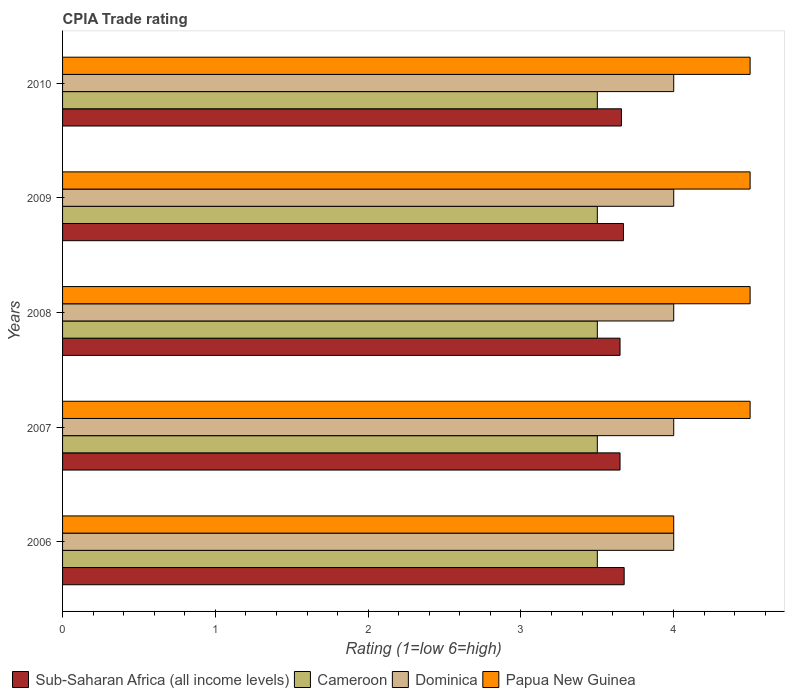Are the number of bars per tick equal to the number of legend labels?
Provide a succinct answer. Yes. How many bars are there on the 1st tick from the top?
Provide a succinct answer. 4. What is the label of the 5th group of bars from the top?
Ensure brevity in your answer.  2006. In how many cases, is the number of bars for a given year not equal to the number of legend labels?
Offer a very short reply. 0. Across all years, what is the maximum CPIA rating in Sub-Saharan Africa (all income levels)?
Offer a terse response. 3.68. Across all years, what is the minimum CPIA rating in Dominica?
Make the answer very short. 4. In which year was the CPIA rating in Dominica minimum?
Your answer should be compact. 2006. What is the total CPIA rating in Papua New Guinea in the graph?
Provide a succinct answer. 22. What is the difference between the CPIA rating in Sub-Saharan Africa (all income levels) in 2006 and that in 2007?
Offer a very short reply. 0.03. What is the difference between the CPIA rating in Cameroon in 2006 and the CPIA rating in Papua New Guinea in 2008?
Your response must be concise. -1. In the year 2007, what is the difference between the CPIA rating in Cameroon and CPIA rating in Sub-Saharan Africa (all income levels)?
Keep it short and to the point. -0.15. What is the ratio of the CPIA rating in Papua New Guinea in 2006 to that in 2009?
Make the answer very short. 0.89. Is the CPIA rating in Dominica in 2007 less than that in 2010?
Offer a very short reply. No. Is the difference between the CPIA rating in Cameroon in 2006 and 2007 greater than the difference between the CPIA rating in Sub-Saharan Africa (all income levels) in 2006 and 2007?
Make the answer very short. No. What is the difference between the highest and the second highest CPIA rating in Dominica?
Make the answer very short. 0. What does the 4th bar from the top in 2007 represents?
Make the answer very short. Sub-Saharan Africa (all income levels). What does the 1st bar from the bottom in 2006 represents?
Offer a very short reply. Sub-Saharan Africa (all income levels). How many bars are there?
Make the answer very short. 20. Are all the bars in the graph horizontal?
Provide a succinct answer. Yes. How many years are there in the graph?
Provide a succinct answer. 5. What is the difference between two consecutive major ticks on the X-axis?
Provide a succinct answer. 1. Does the graph contain grids?
Offer a very short reply. No. How are the legend labels stacked?
Offer a very short reply. Horizontal. What is the title of the graph?
Offer a very short reply. CPIA Trade rating. Does "Papua New Guinea" appear as one of the legend labels in the graph?
Offer a very short reply. Yes. What is the label or title of the Y-axis?
Your answer should be very brief. Years. What is the Rating (1=low 6=high) in Sub-Saharan Africa (all income levels) in 2006?
Give a very brief answer. 3.68. What is the Rating (1=low 6=high) in Sub-Saharan Africa (all income levels) in 2007?
Your response must be concise. 3.65. What is the Rating (1=low 6=high) in Cameroon in 2007?
Make the answer very short. 3.5. What is the Rating (1=low 6=high) in Dominica in 2007?
Make the answer very short. 4. What is the Rating (1=low 6=high) in Sub-Saharan Africa (all income levels) in 2008?
Provide a short and direct response. 3.65. What is the Rating (1=low 6=high) of Cameroon in 2008?
Your answer should be compact. 3.5. What is the Rating (1=low 6=high) of Sub-Saharan Africa (all income levels) in 2009?
Your answer should be very brief. 3.67. What is the Rating (1=low 6=high) of Dominica in 2009?
Provide a short and direct response. 4. What is the Rating (1=low 6=high) of Papua New Guinea in 2009?
Offer a very short reply. 4.5. What is the Rating (1=low 6=high) of Sub-Saharan Africa (all income levels) in 2010?
Offer a very short reply. 3.66. Across all years, what is the maximum Rating (1=low 6=high) in Sub-Saharan Africa (all income levels)?
Offer a very short reply. 3.68. Across all years, what is the maximum Rating (1=low 6=high) of Papua New Guinea?
Keep it short and to the point. 4.5. Across all years, what is the minimum Rating (1=low 6=high) in Sub-Saharan Africa (all income levels)?
Provide a succinct answer. 3.65. What is the total Rating (1=low 6=high) in Sub-Saharan Africa (all income levels) in the graph?
Give a very brief answer. 18.3. What is the total Rating (1=low 6=high) in Cameroon in the graph?
Your response must be concise. 17.5. What is the difference between the Rating (1=low 6=high) of Sub-Saharan Africa (all income levels) in 2006 and that in 2007?
Your response must be concise. 0.03. What is the difference between the Rating (1=low 6=high) of Dominica in 2006 and that in 2007?
Your response must be concise. 0. What is the difference between the Rating (1=low 6=high) in Sub-Saharan Africa (all income levels) in 2006 and that in 2008?
Make the answer very short. 0.03. What is the difference between the Rating (1=low 6=high) of Cameroon in 2006 and that in 2008?
Keep it short and to the point. 0. What is the difference between the Rating (1=low 6=high) of Dominica in 2006 and that in 2008?
Your answer should be compact. 0. What is the difference between the Rating (1=low 6=high) in Sub-Saharan Africa (all income levels) in 2006 and that in 2009?
Ensure brevity in your answer.  0. What is the difference between the Rating (1=low 6=high) in Cameroon in 2006 and that in 2009?
Make the answer very short. 0. What is the difference between the Rating (1=low 6=high) of Sub-Saharan Africa (all income levels) in 2006 and that in 2010?
Offer a terse response. 0.02. What is the difference between the Rating (1=low 6=high) in Papua New Guinea in 2006 and that in 2010?
Your response must be concise. -0.5. What is the difference between the Rating (1=low 6=high) of Papua New Guinea in 2007 and that in 2008?
Give a very brief answer. 0. What is the difference between the Rating (1=low 6=high) of Sub-Saharan Africa (all income levels) in 2007 and that in 2009?
Provide a short and direct response. -0.02. What is the difference between the Rating (1=low 6=high) of Dominica in 2007 and that in 2009?
Your response must be concise. 0. What is the difference between the Rating (1=low 6=high) in Papua New Guinea in 2007 and that in 2009?
Provide a short and direct response. 0. What is the difference between the Rating (1=low 6=high) in Sub-Saharan Africa (all income levels) in 2007 and that in 2010?
Make the answer very short. -0.01. What is the difference between the Rating (1=low 6=high) of Dominica in 2007 and that in 2010?
Provide a short and direct response. 0. What is the difference between the Rating (1=low 6=high) in Sub-Saharan Africa (all income levels) in 2008 and that in 2009?
Your response must be concise. -0.02. What is the difference between the Rating (1=low 6=high) of Sub-Saharan Africa (all income levels) in 2008 and that in 2010?
Offer a terse response. -0.01. What is the difference between the Rating (1=low 6=high) of Cameroon in 2008 and that in 2010?
Provide a short and direct response. 0. What is the difference between the Rating (1=low 6=high) in Sub-Saharan Africa (all income levels) in 2009 and that in 2010?
Your answer should be very brief. 0.01. What is the difference between the Rating (1=low 6=high) of Cameroon in 2009 and that in 2010?
Your answer should be compact. 0. What is the difference between the Rating (1=low 6=high) of Papua New Guinea in 2009 and that in 2010?
Provide a succinct answer. 0. What is the difference between the Rating (1=low 6=high) in Sub-Saharan Africa (all income levels) in 2006 and the Rating (1=low 6=high) in Cameroon in 2007?
Make the answer very short. 0.18. What is the difference between the Rating (1=low 6=high) in Sub-Saharan Africa (all income levels) in 2006 and the Rating (1=low 6=high) in Dominica in 2007?
Your answer should be very brief. -0.32. What is the difference between the Rating (1=low 6=high) in Sub-Saharan Africa (all income levels) in 2006 and the Rating (1=low 6=high) in Papua New Guinea in 2007?
Offer a very short reply. -0.82. What is the difference between the Rating (1=low 6=high) of Cameroon in 2006 and the Rating (1=low 6=high) of Dominica in 2007?
Provide a succinct answer. -0.5. What is the difference between the Rating (1=low 6=high) in Cameroon in 2006 and the Rating (1=low 6=high) in Papua New Guinea in 2007?
Make the answer very short. -1. What is the difference between the Rating (1=low 6=high) in Dominica in 2006 and the Rating (1=low 6=high) in Papua New Guinea in 2007?
Your answer should be compact. -0.5. What is the difference between the Rating (1=low 6=high) in Sub-Saharan Africa (all income levels) in 2006 and the Rating (1=low 6=high) in Cameroon in 2008?
Your answer should be compact. 0.18. What is the difference between the Rating (1=low 6=high) in Sub-Saharan Africa (all income levels) in 2006 and the Rating (1=low 6=high) in Dominica in 2008?
Offer a terse response. -0.32. What is the difference between the Rating (1=low 6=high) of Sub-Saharan Africa (all income levels) in 2006 and the Rating (1=low 6=high) of Papua New Guinea in 2008?
Make the answer very short. -0.82. What is the difference between the Rating (1=low 6=high) of Cameroon in 2006 and the Rating (1=low 6=high) of Dominica in 2008?
Offer a very short reply. -0.5. What is the difference between the Rating (1=low 6=high) of Dominica in 2006 and the Rating (1=low 6=high) of Papua New Guinea in 2008?
Make the answer very short. -0.5. What is the difference between the Rating (1=low 6=high) of Sub-Saharan Africa (all income levels) in 2006 and the Rating (1=low 6=high) of Cameroon in 2009?
Give a very brief answer. 0.18. What is the difference between the Rating (1=low 6=high) in Sub-Saharan Africa (all income levels) in 2006 and the Rating (1=low 6=high) in Dominica in 2009?
Provide a succinct answer. -0.32. What is the difference between the Rating (1=low 6=high) of Sub-Saharan Africa (all income levels) in 2006 and the Rating (1=low 6=high) of Papua New Guinea in 2009?
Ensure brevity in your answer.  -0.82. What is the difference between the Rating (1=low 6=high) in Sub-Saharan Africa (all income levels) in 2006 and the Rating (1=low 6=high) in Cameroon in 2010?
Keep it short and to the point. 0.18. What is the difference between the Rating (1=low 6=high) in Sub-Saharan Africa (all income levels) in 2006 and the Rating (1=low 6=high) in Dominica in 2010?
Provide a short and direct response. -0.32. What is the difference between the Rating (1=low 6=high) of Sub-Saharan Africa (all income levels) in 2006 and the Rating (1=low 6=high) of Papua New Guinea in 2010?
Keep it short and to the point. -0.82. What is the difference between the Rating (1=low 6=high) of Cameroon in 2006 and the Rating (1=low 6=high) of Papua New Guinea in 2010?
Keep it short and to the point. -1. What is the difference between the Rating (1=low 6=high) in Sub-Saharan Africa (all income levels) in 2007 and the Rating (1=low 6=high) in Cameroon in 2008?
Make the answer very short. 0.15. What is the difference between the Rating (1=low 6=high) of Sub-Saharan Africa (all income levels) in 2007 and the Rating (1=low 6=high) of Dominica in 2008?
Give a very brief answer. -0.35. What is the difference between the Rating (1=low 6=high) in Sub-Saharan Africa (all income levels) in 2007 and the Rating (1=low 6=high) in Papua New Guinea in 2008?
Your answer should be compact. -0.85. What is the difference between the Rating (1=low 6=high) of Dominica in 2007 and the Rating (1=low 6=high) of Papua New Guinea in 2008?
Ensure brevity in your answer.  -0.5. What is the difference between the Rating (1=low 6=high) in Sub-Saharan Africa (all income levels) in 2007 and the Rating (1=low 6=high) in Cameroon in 2009?
Offer a very short reply. 0.15. What is the difference between the Rating (1=low 6=high) in Sub-Saharan Africa (all income levels) in 2007 and the Rating (1=low 6=high) in Dominica in 2009?
Offer a very short reply. -0.35. What is the difference between the Rating (1=low 6=high) in Sub-Saharan Africa (all income levels) in 2007 and the Rating (1=low 6=high) in Papua New Guinea in 2009?
Your answer should be very brief. -0.85. What is the difference between the Rating (1=low 6=high) of Cameroon in 2007 and the Rating (1=low 6=high) of Dominica in 2009?
Your answer should be very brief. -0.5. What is the difference between the Rating (1=low 6=high) of Sub-Saharan Africa (all income levels) in 2007 and the Rating (1=low 6=high) of Cameroon in 2010?
Offer a terse response. 0.15. What is the difference between the Rating (1=low 6=high) of Sub-Saharan Africa (all income levels) in 2007 and the Rating (1=low 6=high) of Dominica in 2010?
Your answer should be very brief. -0.35. What is the difference between the Rating (1=low 6=high) in Sub-Saharan Africa (all income levels) in 2007 and the Rating (1=low 6=high) in Papua New Guinea in 2010?
Offer a very short reply. -0.85. What is the difference between the Rating (1=low 6=high) in Cameroon in 2007 and the Rating (1=low 6=high) in Dominica in 2010?
Your answer should be very brief. -0.5. What is the difference between the Rating (1=low 6=high) of Cameroon in 2007 and the Rating (1=low 6=high) of Papua New Guinea in 2010?
Offer a very short reply. -1. What is the difference between the Rating (1=low 6=high) of Sub-Saharan Africa (all income levels) in 2008 and the Rating (1=low 6=high) of Cameroon in 2009?
Ensure brevity in your answer.  0.15. What is the difference between the Rating (1=low 6=high) of Sub-Saharan Africa (all income levels) in 2008 and the Rating (1=low 6=high) of Dominica in 2009?
Provide a short and direct response. -0.35. What is the difference between the Rating (1=low 6=high) in Sub-Saharan Africa (all income levels) in 2008 and the Rating (1=low 6=high) in Papua New Guinea in 2009?
Your answer should be compact. -0.85. What is the difference between the Rating (1=low 6=high) of Cameroon in 2008 and the Rating (1=low 6=high) of Dominica in 2009?
Offer a terse response. -0.5. What is the difference between the Rating (1=low 6=high) in Sub-Saharan Africa (all income levels) in 2008 and the Rating (1=low 6=high) in Cameroon in 2010?
Offer a terse response. 0.15. What is the difference between the Rating (1=low 6=high) of Sub-Saharan Africa (all income levels) in 2008 and the Rating (1=low 6=high) of Dominica in 2010?
Offer a very short reply. -0.35. What is the difference between the Rating (1=low 6=high) of Sub-Saharan Africa (all income levels) in 2008 and the Rating (1=low 6=high) of Papua New Guinea in 2010?
Offer a very short reply. -0.85. What is the difference between the Rating (1=low 6=high) in Cameroon in 2008 and the Rating (1=low 6=high) in Papua New Guinea in 2010?
Provide a succinct answer. -1. What is the difference between the Rating (1=low 6=high) in Sub-Saharan Africa (all income levels) in 2009 and the Rating (1=low 6=high) in Cameroon in 2010?
Ensure brevity in your answer.  0.17. What is the difference between the Rating (1=low 6=high) of Sub-Saharan Africa (all income levels) in 2009 and the Rating (1=low 6=high) of Dominica in 2010?
Provide a short and direct response. -0.33. What is the difference between the Rating (1=low 6=high) in Sub-Saharan Africa (all income levels) in 2009 and the Rating (1=low 6=high) in Papua New Guinea in 2010?
Ensure brevity in your answer.  -0.83. What is the difference between the Rating (1=low 6=high) in Cameroon in 2009 and the Rating (1=low 6=high) in Papua New Guinea in 2010?
Offer a terse response. -1. What is the average Rating (1=low 6=high) in Sub-Saharan Africa (all income levels) per year?
Give a very brief answer. 3.66. What is the average Rating (1=low 6=high) in Dominica per year?
Give a very brief answer. 4. In the year 2006, what is the difference between the Rating (1=low 6=high) of Sub-Saharan Africa (all income levels) and Rating (1=low 6=high) of Cameroon?
Provide a succinct answer. 0.18. In the year 2006, what is the difference between the Rating (1=low 6=high) in Sub-Saharan Africa (all income levels) and Rating (1=low 6=high) in Dominica?
Keep it short and to the point. -0.32. In the year 2006, what is the difference between the Rating (1=low 6=high) of Sub-Saharan Africa (all income levels) and Rating (1=low 6=high) of Papua New Guinea?
Ensure brevity in your answer.  -0.32. In the year 2007, what is the difference between the Rating (1=low 6=high) of Sub-Saharan Africa (all income levels) and Rating (1=low 6=high) of Cameroon?
Offer a very short reply. 0.15. In the year 2007, what is the difference between the Rating (1=low 6=high) in Sub-Saharan Africa (all income levels) and Rating (1=low 6=high) in Dominica?
Your response must be concise. -0.35. In the year 2007, what is the difference between the Rating (1=low 6=high) of Sub-Saharan Africa (all income levels) and Rating (1=low 6=high) of Papua New Guinea?
Make the answer very short. -0.85. In the year 2007, what is the difference between the Rating (1=low 6=high) in Cameroon and Rating (1=low 6=high) in Papua New Guinea?
Make the answer very short. -1. In the year 2007, what is the difference between the Rating (1=low 6=high) of Dominica and Rating (1=low 6=high) of Papua New Guinea?
Your response must be concise. -0.5. In the year 2008, what is the difference between the Rating (1=low 6=high) of Sub-Saharan Africa (all income levels) and Rating (1=low 6=high) of Cameroon?
Make the answer very short. 0.15. In the year 2008, what is the difference between the Rating (1=low 6=high) in Sub-Saharan Africa (all income levels) and Rating (1=low 6=high) in Dominica?
Offer a very short reply. -0.35. In the year 2008, what is the difference between the Rating (1=low 6=high) of Sub-Saharan Africa (all income levels) and Rating (1=low 6=high) of Papua New Guinea?
Your response must be concise. -0.85. In the year 2008, what is the difference between the Rating (1=low 6=high) in Cameroon and Rating (1=low 6=high) in Dominica?
Provide a succinct answer. -0.5. In the year 2008, what is the difference between the Rating (1=low 6=high) in Cameroon and Rating (1=low 6=high) in Papua New Guinea?
Provide a short and direct response. -1. In the year 2008, what is the difference between the Rating (1=low 6=high) in Dominica and Rating (1=low 6=high) in Papua New Guinea?
Provide a short and direct response. -0.5. In the year 2009, what is the difference between the Rating (1=low 6=high) of Sub-Saharan Africa (all income levels) and Rating (1=low 6=high) of Cameroon?
Ensure brevity in your answer.  0.17. In the year 2009, what is the difference between the Rating (1=low 6=high) in Sub-Saharan Africa (all income levels) and Rating (1=low 6=high) in Dominica?
Ensure brevity in your answer.  -0.33. In the year 2009, what is the difference between the Rating (1=low 6=high) of Sub-Saharan Africa (all income levels) and Rating (1=low 6=high) of Papua New Guinea?
Make the answer very short. -0.83. In the year 2009, what is the difference between the Rating (1=low 6=high) in Cameroon and Rating (1=low 6=high) in Dominica?
Your answer should be very brief. -0.5. In the year 2009, what is the difference between the Rating (1=low 6=high) of Cameroon and Rating (1=low 6=high) of Papua New Guinea?
Provide a succinct answer. -1. In the year 2010, what is the difference between the Rating (1=low 6=high) in Sub-Saharan Africa (all income levels) and Rating (1=low 6=high) in Cameroon?
Provide a short and direct response. 0.16. In the year 2010, what is the difference between the Rating (1=low 6=high) of Sub-Saharan Africa (all income levels) and Rating (1=low 6=high) of Dominica?
Provide a succinct answer. -0.34. In the year 2010, what is the difference between the Rating (1=low 6=high) of Sub-Saharan Africa (all income levels) and Rating (1=low 6=high) of Papua New Guinea?
Keep it short and to the point. -0.84. In the year 2010, what is the difference between the Rating (1=low 6=high) in Cameroon and Rating (1=low 6=high) in Dominica?
Ensure brevity in your answer.  -0.5. In the year 2010, what is the difference between the Rating (1=low 6=high) of Dominica and Rating (1=low 6=high) of Papua New Guinea?
Ensure brevity in your answer.  -0.5. What is the ratio of the Rating (1=low 6=high) in Sub-Saharan Africa (all income levels) in 2006 to that in 2007?
Offer a terse response. 1.01. What is the ratio of the Rating (1=low 6=high) in Cameroon in 2006 to that in 2007?
Provide a succinct answer. 1. What is the ratio of the Rating (1=low 6=high) in Dominica in 2006 to that in 2007?
Make the answer very short. 1. What is the ratio of the Rating (1=low 6=high) of Sub-Saharan Africa (all income levels) in 2006 to that in 2008?
Keep it short and to the point. 1.01. What is the ratio of the Rating (1=low 6=high) of Cameroon in 2006 to that in 2009?
Give a very brief answer. 1. What is the ratio of the Rating (1=low 6=high) in Sub-Saharan Africa (all income levels) in 2006 to that in 2010?
Your answer should be very brief. 1. What is the ratio of the Rating (1=low 6=high) of Dominica in 2006 to that in 2010?
Offer a terse response. 1. What is the ratio of the Rating (1=low 6=high) of Sub-Saharan Africa (all income levels) in 2007 to that in 2008?
Offer a terse response. 1. What is the ratio of the Rating (1=low 6=high) in Papua New Guinea in 2007 to that in 2008?
Your answer should be very brief. 1. What is the ratio of the Rating (1=low 6=high) of Cameroon in 2007 to that in 2009?
Your answer should be compact. 1. What is the ratio of the Rating (1=low 6=high) of Dominica in 2007 to that in 2009?
Offer a terse response. 1. What is the ratio of the Rating (1=low 6=high) in Papua New Guinea in 2007 to that in 2009?
Make the answer very short. 1. What is the ratio of the Rating (1=low 6=high) of Papua New Guinea in 2007 to that in 2010?
Keep it short and to the point. 1. What is the ratio of the Rating (1=low 6=high) in Papua New Guinea in 2008 to that in 2009?
Make the answer very short. 1. What is the ratio of the Rating (1=low 6=high) of Cameroon in 2008 to that in 2010?
Your response must be concise. 1. What is the ratio of the Rating (1=low 6=high) in Dominica in 2008 to that in 2010?
Ensure brevity in your answer.  1. What is the ratio of the Rating (1=low 6=high) of Papua New Guinea in 2008 to that in 2010?
Offer a very short reply. 1. What is the ratio of the Rating (1=low 6=high) of Sub-Saharan Africa (all income levels) in 2009 to that in 2010?
Ensure brevity in your answer.  1. What is the ratio of the Rating (1=low 6=high) of Cameroon in 2009 to that in 2010?
Provide a succinct answer. 1. What is the ratio of the Rating (1=low 6=high) of Papua New Guinea in 2009 to that in 2010?
Make the answer very short. 1. What is the difference between the highest and the second highest Rating (1=low 6=high) in Sub-Saharan Africa (all income levels)?
Offer a very short reply. 0. What is the difference between the highest and the second highest Rating (1=low 6=high) of Cameroon?
Provide a short and direct response. 0. What is the difference between the highest and the second highest Rating (1=low 6=high) in Dominica?
Ensure brevity in your answer.  0. What is the difference between the highest and the second highest Rating (1=low 6=high) in Papua New Guinea?
Keep it short and to the point. 0. What is the difference between the highest and the lowest Rating (1=low 6=high) of Sub-Saharan Africa (all income levels)?
Keep it short and to the point. 0.03. What is the difference between the highest and the lowest Rating (1=low 6=high) in Cameroon?
Give a very brief answer. 0. What is the difference between the highest and the lowest Rating (1=low 6=high) of Papua New Guinea?
Ensure brevity in your answer.  0.5. 